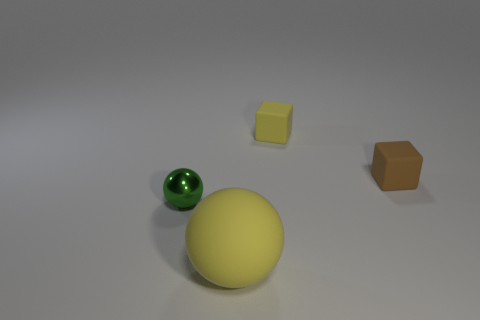How many rubber cubes are in front of the tiny yellow rubber cube behind the sphere that is behind the yellow ball?
Give a very brief answer. 1. What material is the object that is the same color as the large rubber sphere?
Your answer should be compact. Rubber. Are there any other things that are the same shape as the small brown thing?
Your answer should be compact. Yes. What number of things are objects that are behind the metallic ball or green spheres?
Make the answer very short. 3. There is a ball that is in front of the small green shiny ball; is it the same color as the small shiny object?
Your answer should be very brief. No. What shape is the thing that is left of the large ball that is on the right side of the green thing?
Offer a terse response. Sphere. Is the number of objects behind the green thing less than the number of yellow cubes that are right of the tiny yellow rubber cube?
Offer a terse response. No. What is the size of the yellow rubber object that is the same shape as the small metallic thing?
Keep it short and to the point. Large. Is there any other thing that has the same size as the yellow cube?
Give a very brief answer. Yes. What number of things are either small objects in front of the small brown matte thing or balls that are in front of the small green object?
Keep it short and to the point. 2. 